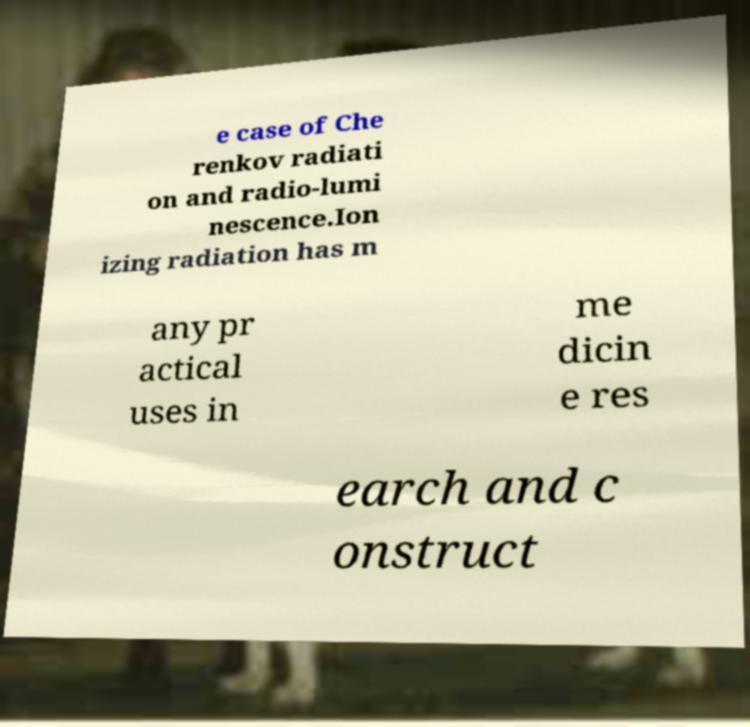For documentation purposes, I need the text within this image transcribed. Could you provide that? e case of Che renkov radiati on and radio-lumi nescence.Ion izing radiation has m any pr actical uses in me dicin e res earch and c onstruct 